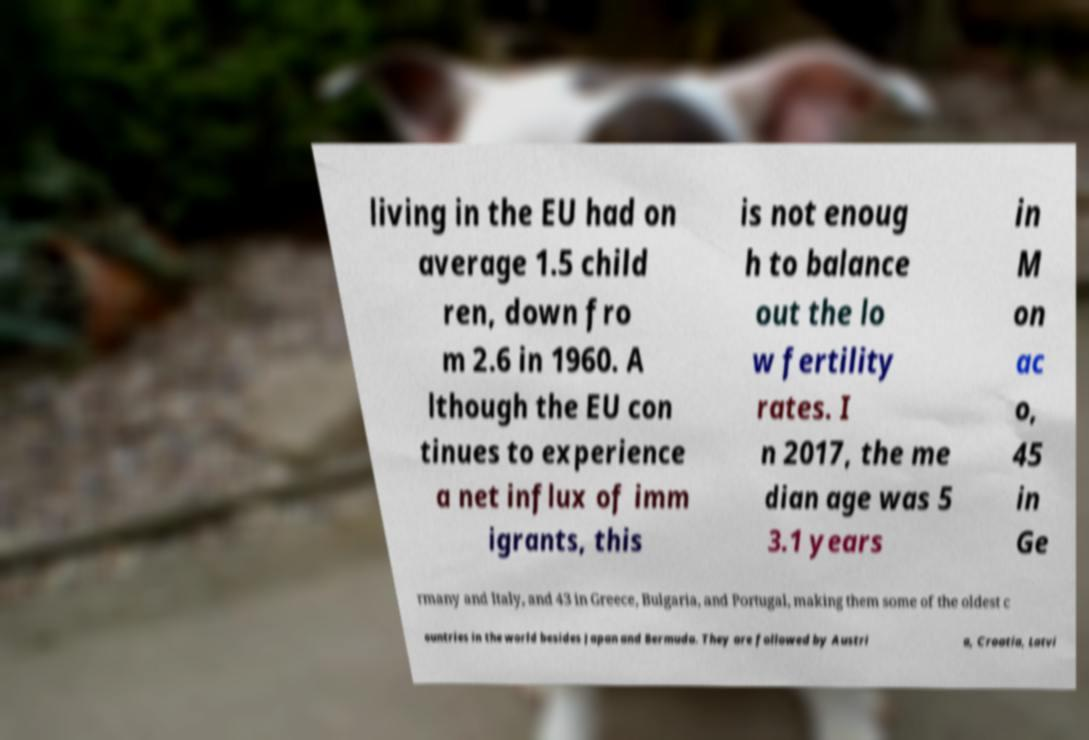What messages or text are displayed in this image? I need them in a readable, typed format. living in the EU had on average 1.5 child ren, down fro m 2.6 in 1960. A lthough the EU con tinues to experience a net influx of imm igrants, this is not enoug h to balance out the lo w fertility rates. I n 2017, the me dian age was 5 3.1 years in M on ac o, 45 in Ge rmany and Italy, and 43 in Greece, Bulgaria, and Portugal, making them some of the oldest c ountries in the world besides Japan and Bermuda. They are followed by Austri a, Croatia, Latvi 